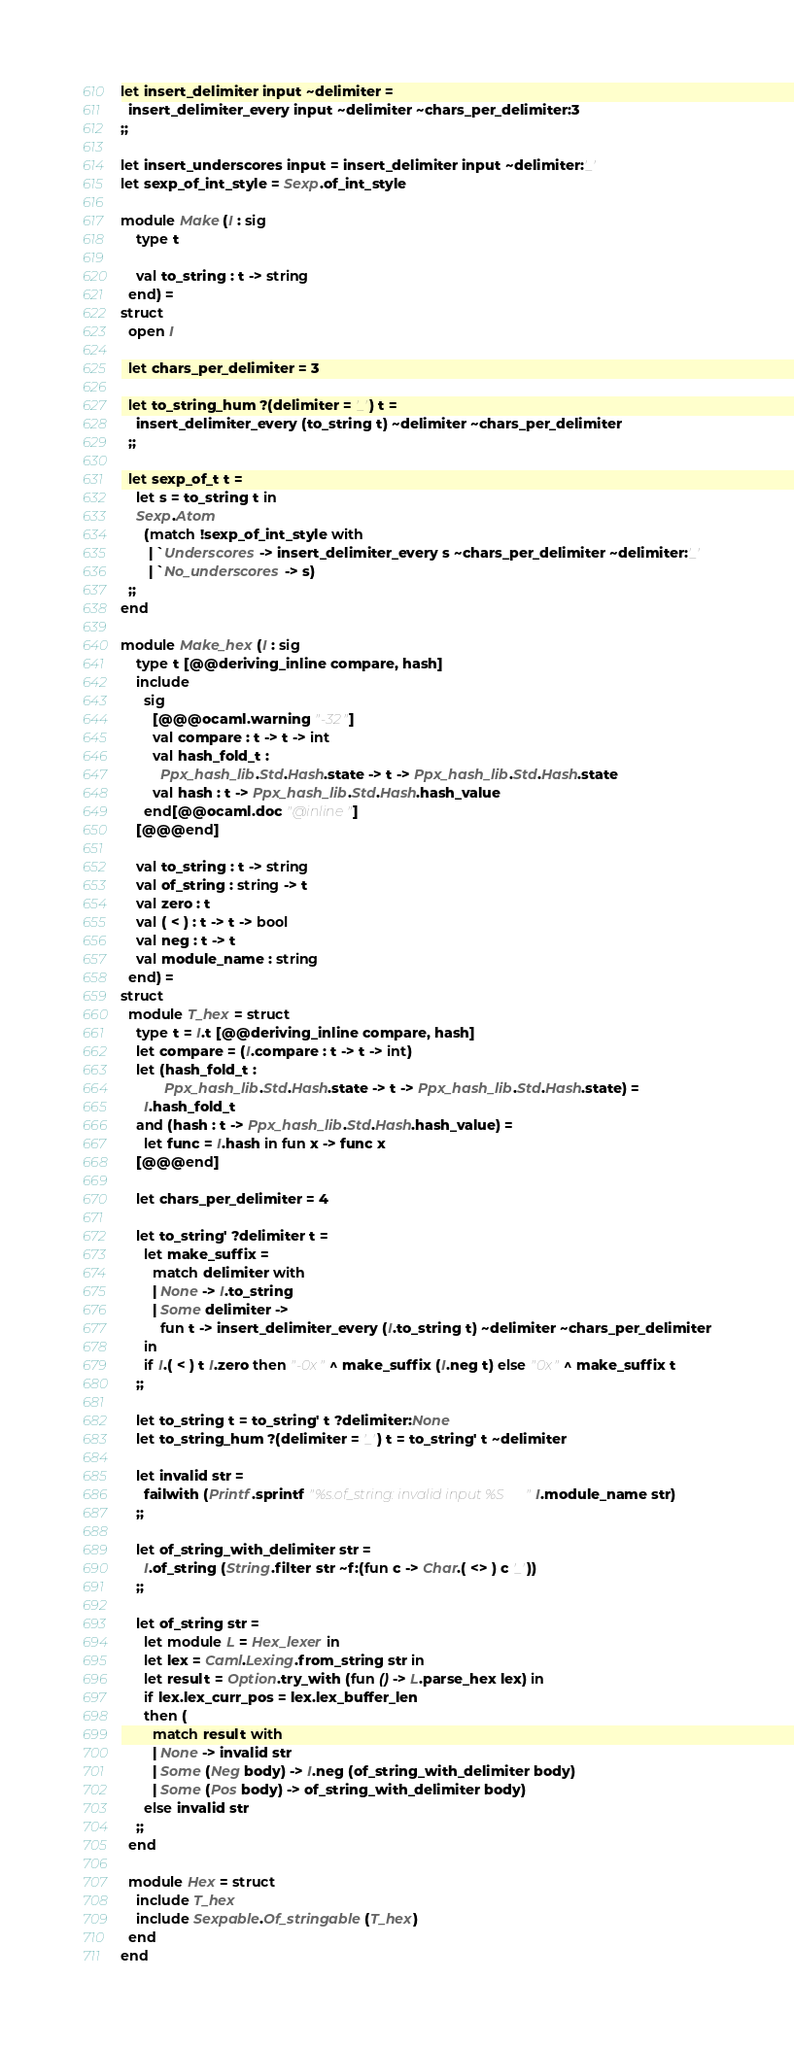<code> <loc_0><loc_0><loc_500><loc_500><_OCaml_>let insert_delimiter input ~delimiter =
  insert_delimiter_every input ~delimiter ~chars_per_delimiter:3
;;

let insert_underscores input = insert_delimiter input ~delimiter:'_'
let sexp_of_int_style = Sexp.of_int_style

module Make (I : sig
    type t

    val to_string : t -> string
  end) =
struct
  open I

  let chars_per_delimiter = 3

  let to_string_hum ?(delimiter = '_') t =
    insert_delimiter_every (to_string t) ~delimiter ~chars_per_delimiter
  ;;

  let sexp_of_t t =
    let s = to_string t in
    Sexp.Atom
      (match !sexp_of_int_style with
       | `Underscores -> insert_delimiter_every s ~chars_per_delimiter ~delimiter:'_'
       | `No_underscores -> s)
  ;;
end

module Make_hex (I : sig
    type t [@@deriving_inline compare, hash]
    include
      sig
        [@@@ocaml.warning "-32"]
        val compare : t -> t -> int
        val hash_fold_t :
          Ppx_hash_lib.Std.Hash.state -> t -> Ppx_hash_lib.Std.Hash.state
        val hash : t -> Ppx_hash_lib.Std.Hash.hash_value
      end[@@ocaml.doc "@inline"]
    [@@@end]

    val to_string : t -> string
    val of_string : string -> t
    val zero : t
    val ( < ) : t -> t -> bool
    val neg : t -> t
    val module_name : string
  end) =
struct
  module T_hex = struct
    type t = I.t [@@deriving_inline compare, hash]
    let compare = (I.compare : t -> t -> int)
    let (hash_fold_t :
           Ppx_hash_lib.Std.Hash.state -> t -> Ppx_hash_lib.Std.Hash.state) =
      I.hash_fold_t
    and (hash : t -> Ppx_hash_lib.Std.Hash.hash_value) =
      let func = I.hash in fun x -> func x
    [@@@end]

    let chars_per_delimiter = 4

    let to_string' ?delimiter t =
      let make_suffix =
        match delimiter with
        | None -> I.to_string
        | Some delimiter ->
          fun t -> insert_delimiter_every (I.to_string t) ~delimiter ~chars_per_delimiter
      in
      if I.( < ) t I.zero then "-0x" ^ make_suffix (I.neg t) else "0x" ^ make_suffix t
    ;;

    let to_string t = to_string' t ?delimiter:None
    let to_string_hum ?(delimiter = '_') t = to_string' t ~delimiter

    let invalid str =
      failwith (Printf.sprintf "%s.of_string: invalid input %S" I.module_name str)
    ;;

    let of_string_with_delimiter str =
      I.of_string (String.filter str ~f:(fun c -> Char.( <> ) c '_'))
    ;;

    let of_string str =
      let module L = Hex_lexer in
      let lex = Caml.Lexing.from_string str in
      let result = Option.try_with (fun () -> L.parse_hex lex) in
      if lex.lex_curr_pos = lex.lex_buffer_len
      then (
        match result with
        | None -> invalid str
        | Some (Neg body) -> I.neg (of_string_with_delimiter body)
        | Some (Pos body) -> of_string_with_delimiter body)
      else invalid str
    ;;
  end

  module Hex = struct
    include T_hex
    include Sexpable.Of_stringable (T_hex)
  end
end
</code> 